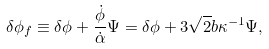<formula> <loc_0><loc_0><loc_500><loc_500>\delta \phi _ { f } \equiv \delta \phi + \frac { \dot { \phi } } { \dot { \alpha } } \Psi = \delta \phi + 3 \sqrt { 2 } b \kappa ^ { - 1 } \Psi ,</formula> 